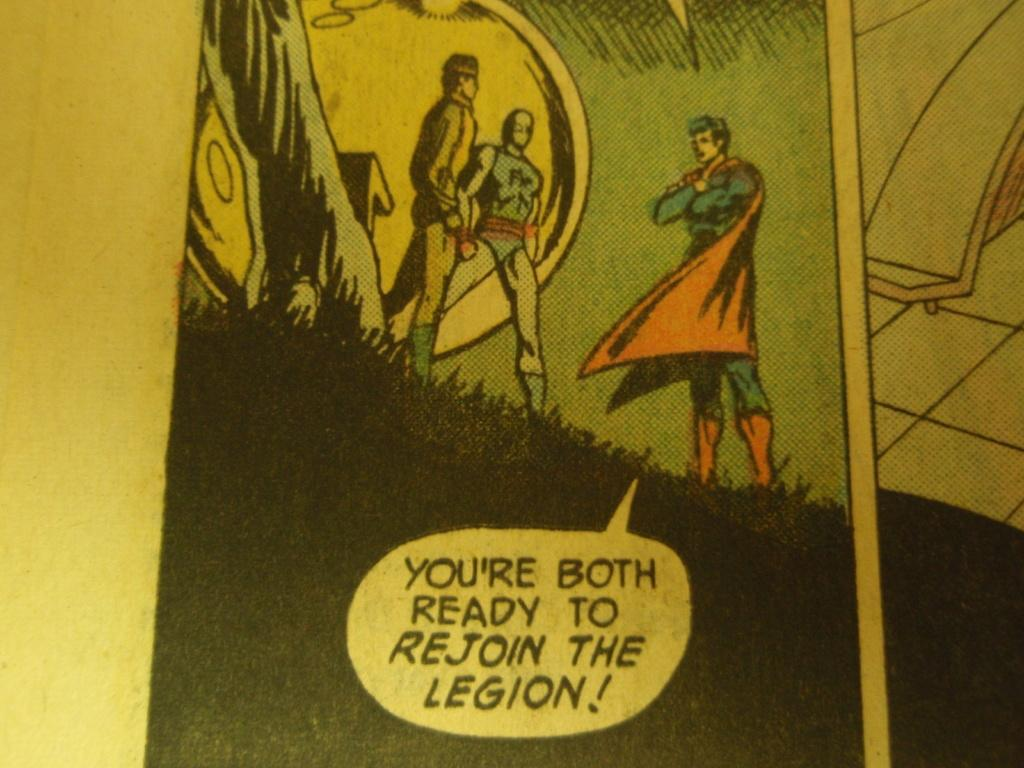<image>
Relay a brief, clear account of the picture shown. superman standing in grass talking to two others about rejoining the legion 